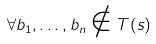Convert formula to latex. <formula><loc_0><loc_0><loc_500><loc_500>\forall b _ { 1 } , \dots , b _ { n } \notin T ( s )</formula> 